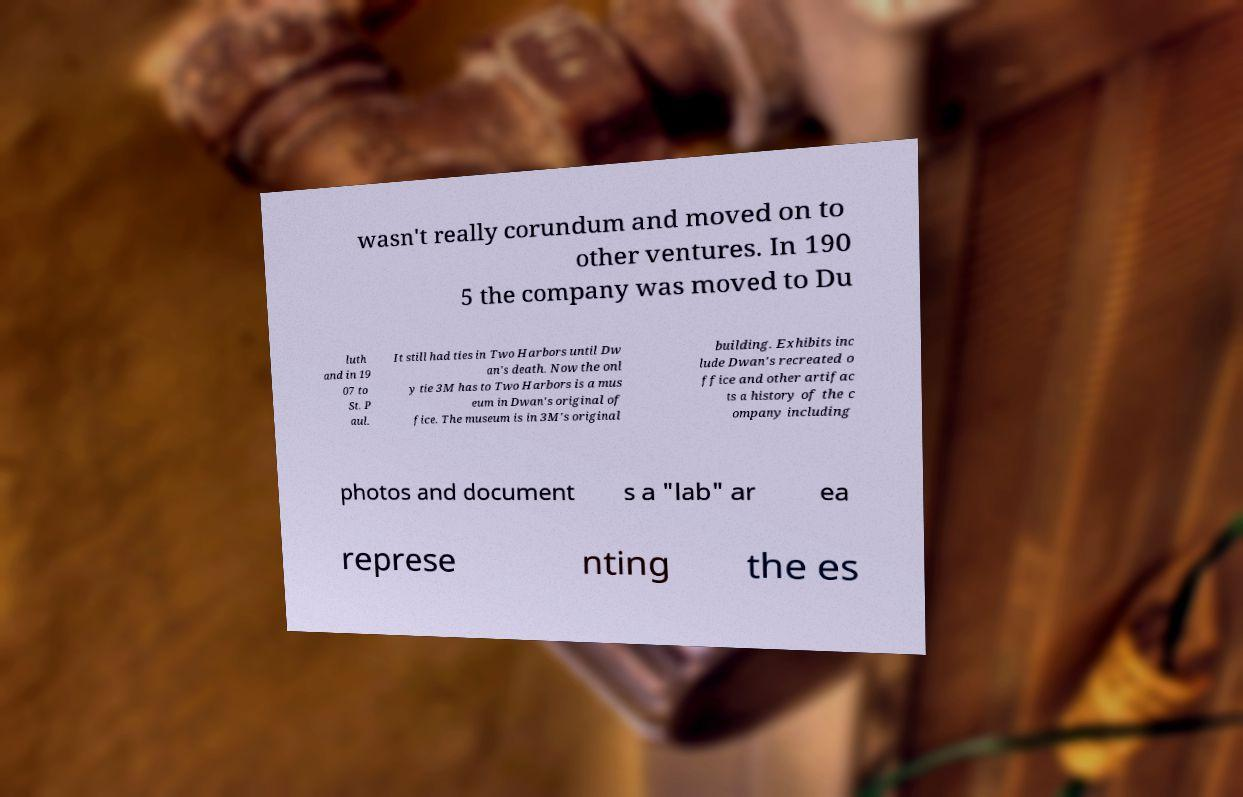I need the written content from this picture converted into text. Can you do that? wasn't really corundum and moved on to other ventures. In 190 5 the company was moved to Du luth and in 19 07 to St. P aul. It still had ties in Two Harbors until Dw an's death. Now the onl y tie 3M has to Two Harbors is a mus eum in Dwan's original of fice. The museum is in 3M's original building. Exhibits inc lude Dwan's recreated o ffice and other artifac ts a history of the c ompany including photos and document s a "lab" ar ea represe nting the es 